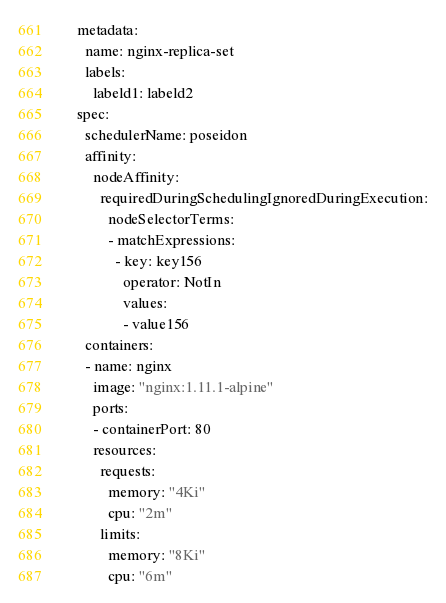<code> <loc_0><loc_0><loc_500><loc_500><_YAML_>    metadata:
      name: nginx-replica-set
      labels:
        labeld1: labeld2
    spec:
      schedulerName: poseidon
      affinity:
        nodeAffinity:
          requiredDuringSchedulingIgnoredDuringExecution:
            nodeSelectorTerms:
            - matchExpressions:
              - key: key156
                operator: NotIn
                values:
                - value156
      containers:
      - name: nginx
        image: "nginx:1.11.1-alpine"
        ports:
        - containerPort: 80
        resources:
          requests:
            memory: "4Ki"
            cpu: "2m"
          limits:
            memory: "8Ki"
            cpu: "6m"
</code> 